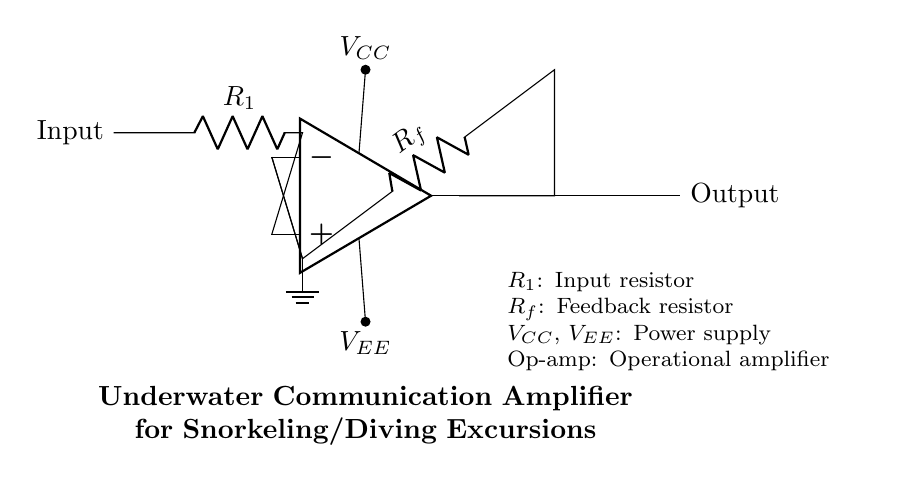What type of circuit is this? This circuit is classified as an operational amplifier circuit. The presence of an op-amp symbol indicates that the circuit is designed to amplify signals, typical for operational amplifier configurations.
Answer: operational amplifier What are the value designations next to the resistors? The designation next to the resistors indicates their role in the circuit; there's R1 denoting the input resistor and Rf representing the feedback resistor. These values are critical in determining the gain of the amplifier.
Answer: R1, Rf Where do the power supplies connect? The power supplies connect to the op-amp; VCC connects to the upper terminal of the op-amp and VEE connects to the lower terminal. This is required for the op-amp to function correctly and provide the necessary amplification.
Answer: VCC, VEE What is the purpose of the feedback resistor Rf? The feedback resistor Rf is used to regulate the output signal by feeding a portion back to the inverting input of the op-amp. This controls the gain of the amplifier, determining how much the input signal is amplified.
Answer: gain control What is the function of the input signal in this circuit? The input signal is applied to the non-inverting terminal of the op-amp through the input resistor R1, allowing the circuit to amplify the input signal for underwater communication.
Answer: signal amplification Why is there a ground connection in this circuit? Ground connection is crucial because it serves as a reference point for the voltage levels in the circuit. It ensures stability in the circuit’s operation by providing a zero-voltage reference level essential for proper amplifier functioning.
Answer: reference point 